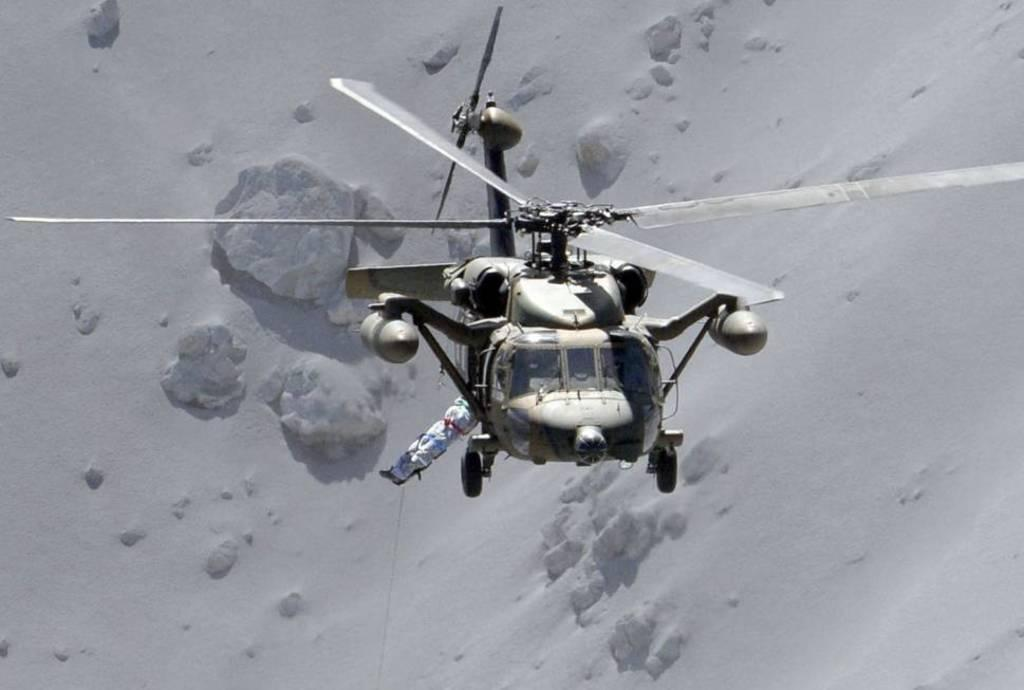What is the main subject of the image? The main subject of the image is a helicopter. What is the helicopter doing in the image? The helicopter is flying in the sky. Can you describe the background of the image? The background appears to be white, possibly indicating snow. What type of plants can be seen growing near the helicopter in the image? There are no plants visible in the image; the helicopter is flying in the sky. What flavor of mint is being used to fuel the helicopter in the image? There is no mention of mint or any fuel source in the image; the helicopter is simply flying in the sky. 